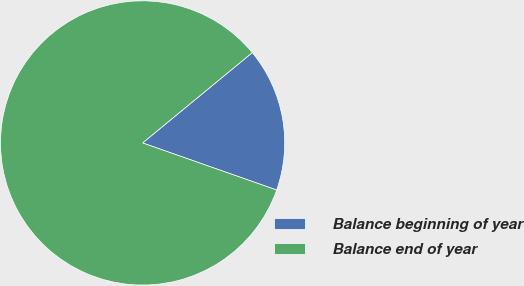<chart> <loc_0><loc_0><loc_500><loc_500><pie_chart><fcel>Balance beginning of year<fcel>Balance end of year<nl><fcel>16.34%<fcel>83.66%<nl></chart> 